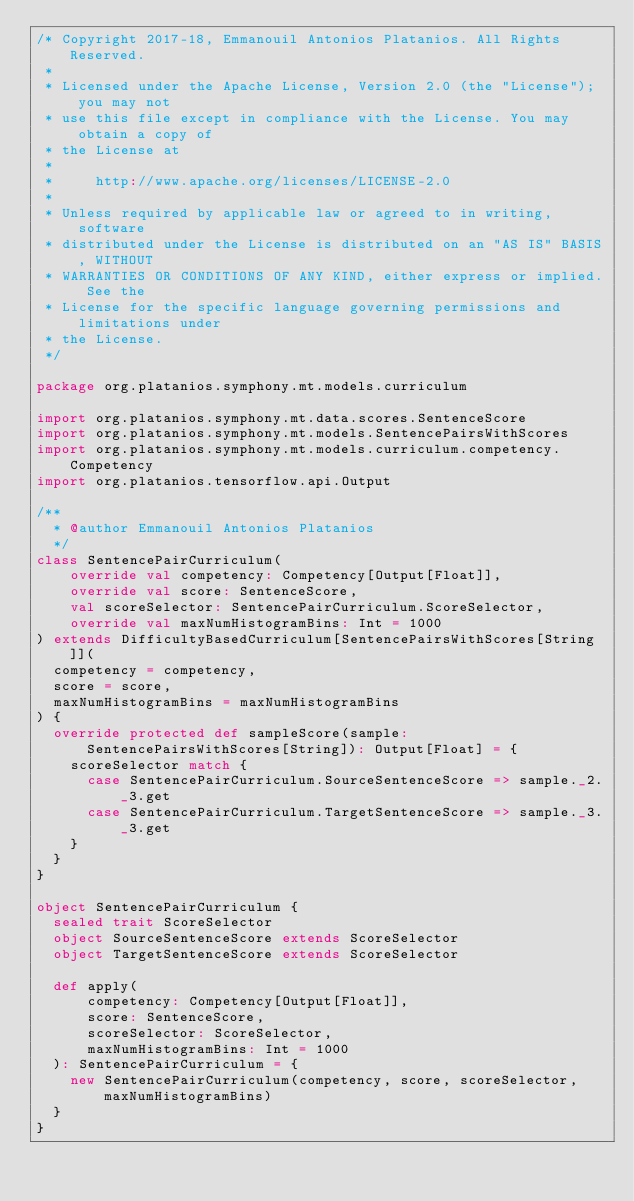Convert code to text. <code><loc_0><loc_0><loc_500><loc_500><_Scala_>/* Copyright 2017-18, Emmanouil Antonios Platanios. All Rights Reserved.
 *
 * Licensed under the Apache License, Version 2.0 (the "License"); you may not
 * use this file except in compliance with the License. You may obtain a copy of
 * the License at
 *
 *     http://www.apache.org/licenses/LICENSE-2.0
 *
 * Unless required by applicable law or agreed to in writing, software
 * distributed under the License is distributed on an "AS IS" BASIS, WITHOUT
 * WARRANTIES OR CONDITIONS OF ANY KIND, either express or implied. See the
 * License for the specific language governing permissions and limitations under
 * the License.
 */

package org.platanios.symphony.mt.models.curriculum

import org.platanios.symphony.mt.data.scores.SentenceScore
import org.platanios.symphony.mt.models.SentencePairsWithScores
import org.platanios.symphony.mt.models.curriculum.competency.Competency
import org.platanios.tensorflow.api.Output

/**
  * @author Emmanouil Antonios Platanios
  */
class SentencePairCurriculum(
    override val competency: Competency[Output[Float]],
    override val score: SentenceScore,
    val scoreSelector: SentencePairCurriculum.ScoreSelector,
    override val maxNumHistogramBins: Int = 1000
) extends DifficultyBasedCurriculum[SentencePairsWithScores[String]](
  competency = competency,
  score = score,
  maxNumHistogramBins = maxNumHistogramBins
) {
  override protected def sampleScore(sample: SentencePairsWithScores[String]): Output[Float] = {
    scoreSelector match {
      case SentencePairCurriculum.SourceSentenceScore => sample._2._3.get
      case SentencePairCurriculum.TargetSentenceScore => sample._3._3.get
    }
  }
}

object SentencePairCurriculum {
  sealed trait ScoreSelector
  object SourceSentenceScore extends ScoreSelector
  object TargetSentenceScore extends ScoreSelector

  def apply(
      competency: Competency[Output[Float]],
      score: SentenceScore,
      scoreSelector: ScoreSelector,
      maxNumHistogramBins: Int = 1000
  ): SentencePairCurriculum = {
    new SentencePairCurriculum(competency, score, scoreSelector, maxNumHistogramBins)
  }
}
</code> 